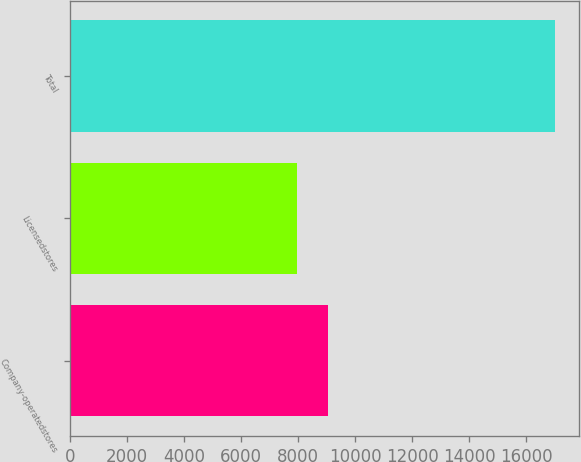Convert chart. <chart><loc_0><loc_0><loc_500><loc_500><bar_chart><fcel>Company-operatedstores<fcel>Licensedstores<fcel>Total<nl><fcel>9031<fcel>7972<fcel>17003<nl></chart> 